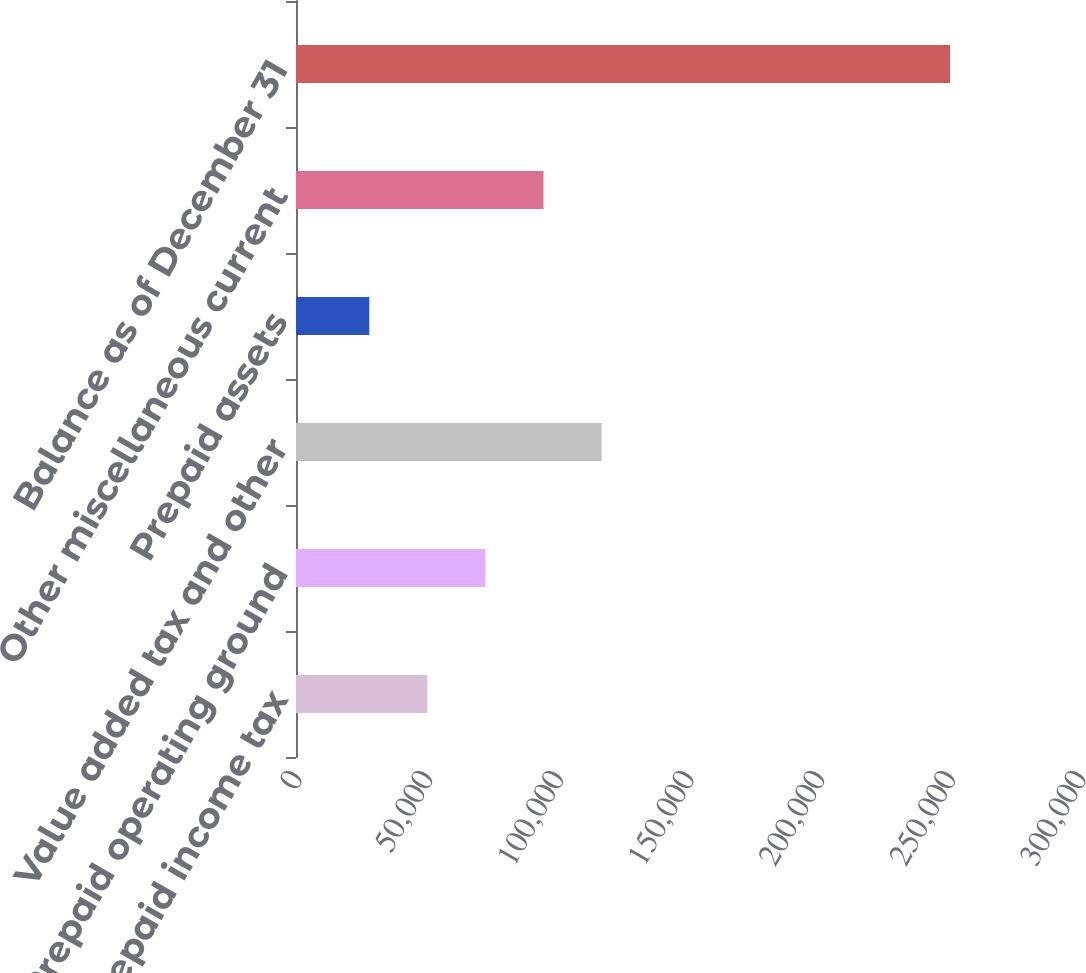<chart> <loc_0><loc_0><loc_500><loc_500><bar_chart><fcel>Prepaid income tax<fcel>Prepaid operating ground<fcel>Value added tax and other<fcel>Prepaid assets<fcel>Other miscellaneous current<fcel>Balance as of December 31<nl><fcel>50255.2<fcel>72479.4<fcel>116928<fcel>28031<fcel>94703.6<fcel>250273<nl></chart> 